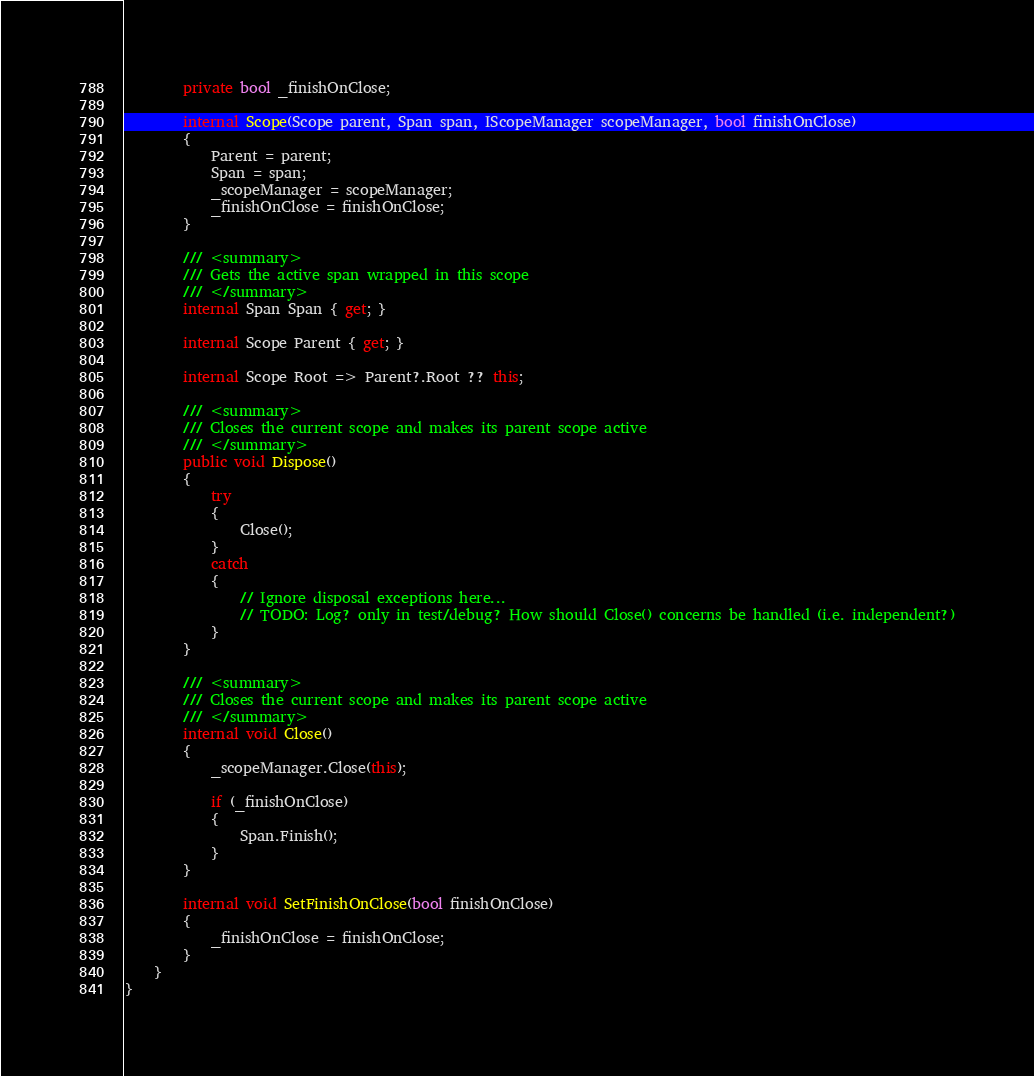Convert code to text. <code><loc_0><loc_0><loc_500><loc_500><_C#_>        private bool _finishOnClose;

        internal Scope(Scope parent, Span span, IScopeManager scopeManager, bool finishOnClose)
        {
            Parent = parent;
            Span = span;
            _scopeManager = scopeManager;
            _finishOnClose = finishOnClose;
        }

        /// <summary>
        /// Gets the active span wrapped in this scope
        /// </summary>
        internal Span Span { get; }

        internal Scope Parent { get; }

        internal Scope Root => Parent?.Root ?? this;

        /// <summary>
        /// Closes the current scope and makes its parent scope active
        /// </summary>
        public void Dispose()
        {
            try
            {
                Close();
            }
            catch
            {
                // Ignore disposal exceptions here...
                // TODO: Log? only in test/debug? How should Close() concerns be handled (i.e. independent?)
            }
        }

        /// <summary>
        /// Closes the current scope and makes its parent scope active
        /// </summary>
        internal void Close()
        {
            _scopeManager.Close(this);

            if (_finishOnClose)
            {
                Span.Finish();
            }
        }

        internal void SetFinishOnClose(bool finishOnClose)
        {
            _finishOnClose = finishOnClose;
        }
    }
}
</code> 